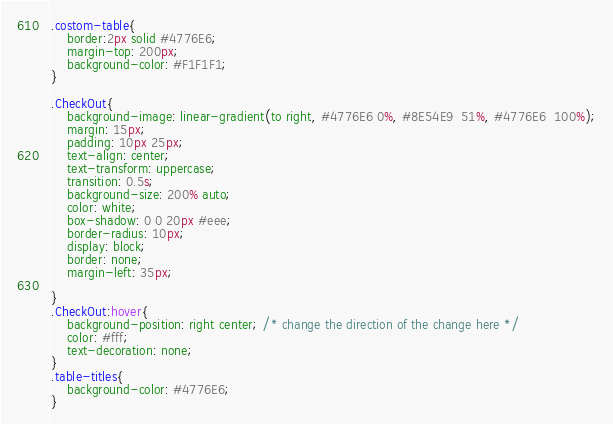Convert code to text. <code><loc_0><loc_0><loc_500><loc_500><_CSS_>.costom-table{
    border:2px solid #4776E6;
    margin-top: 200px;
    background-color: #F1F1F1;
}

.CheckOut{
    background-image: linear-gradient(to right, #4776E6 0%, #8E54E9  51%, #4776E6  100%);
    margin: 15px;
    padding: 10px 25px;
    text-align: center;
    text-transform: uppercase;
    transition: 0.5s;
    background-size: 200% auto;
    color: white;            
    box-shadow: 0 0 20px #eee;
    border-radius: 10px;
    display: block;
    border: none;
    margin-left: 35px;

}
.CheckOut:hover{
    background-position: right center; /* change the direction of the change here */
    color: #fff;
    text-decoration: none;
}
.table-titles{
    background-color: #4776E6;
}</code> 